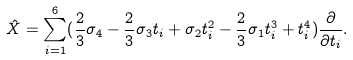Convert formula to latex. <formula><loc_0><loc_0><loc_500><loc_500>\hat { X } = \sum _ { i = 1 } ^ { 6 } ( \frac { 2 } { 3 } \sigma _ { 4 } - \frac { 2 } { 3 } \sigma _ { 3 } t _ { i } + \sigma _ { 2 } t _ { i } ^ { 2 } - \frac { 2 } { 3 } \sigma _ { 1 } t _ { i } ^ { 3 } + t _ { i } ^ { 4 } ) \frac { \partial } { \partial t _ { i } } .</formula> 